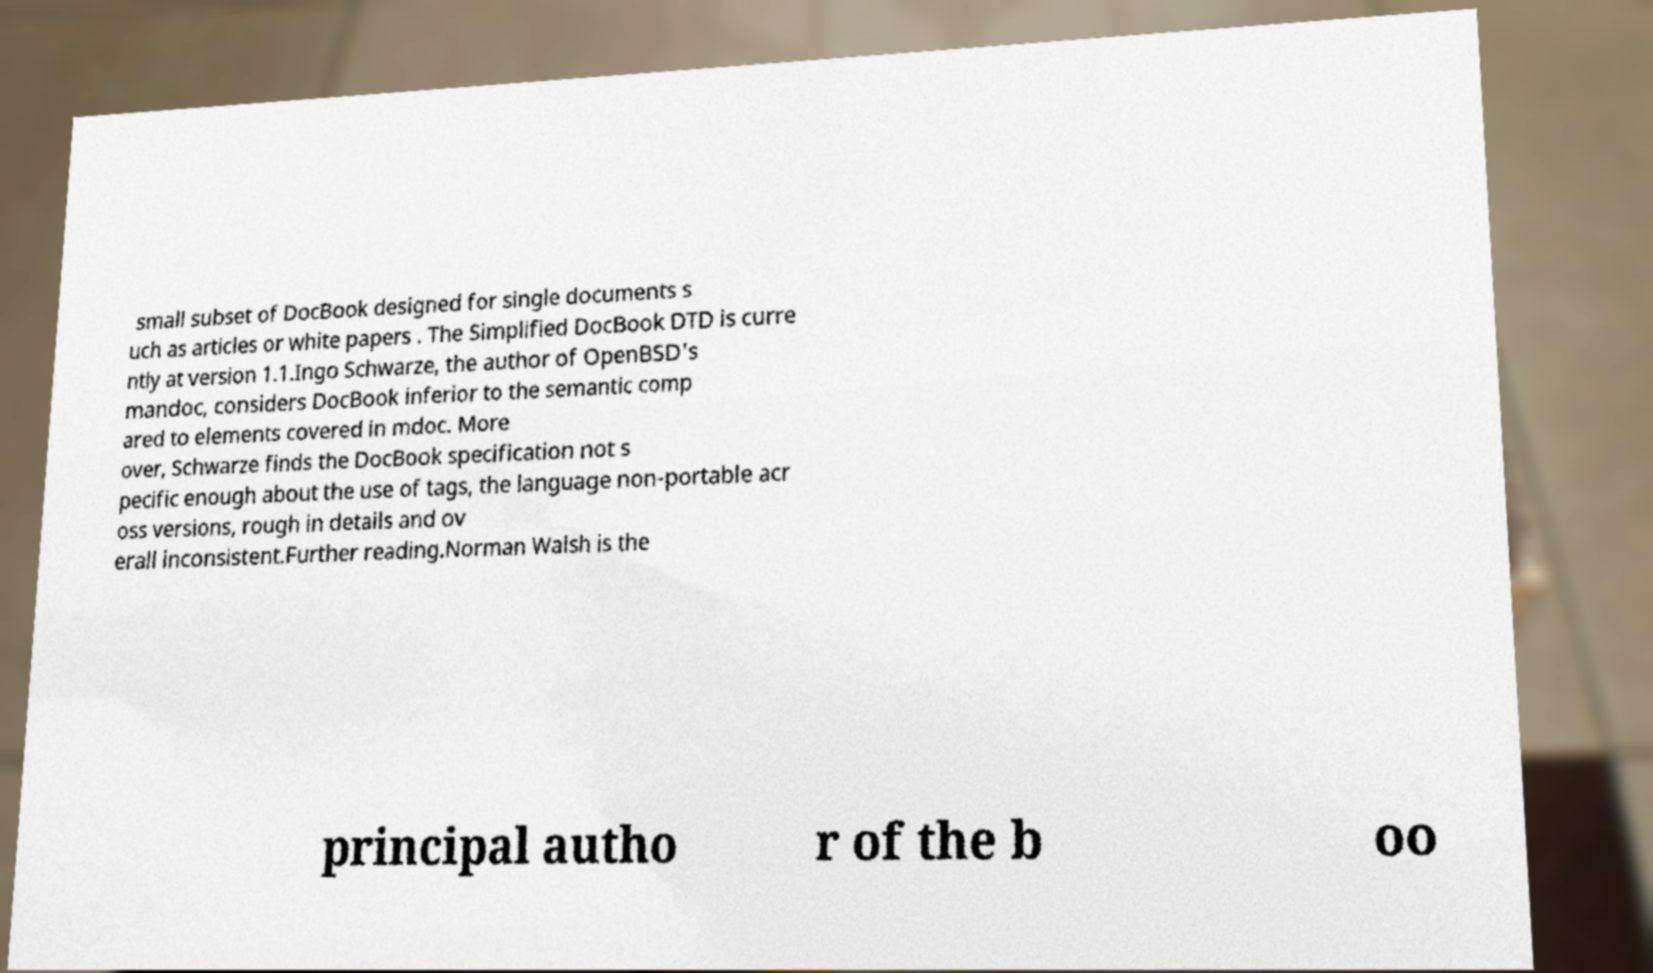Please identify and transcribe the text found in this image. small subset of DocBook designed for single documents s uch as articles or white papers . The Simplified DocBook DTD is curre ntly at version 1.1.Ingo Schwarze, the author of OpenBSD's mandoc, considers DocBook inferior to the semantic comp ared to elements covered in mdoc. More over, Schwarze finds the DocBook specification not s pecific enough about the use of tags, the language non-portable acr oss versions, rough in details and ov erall inconsistent.Further reading.Norman Walsh is the principal autho r of the b oo 